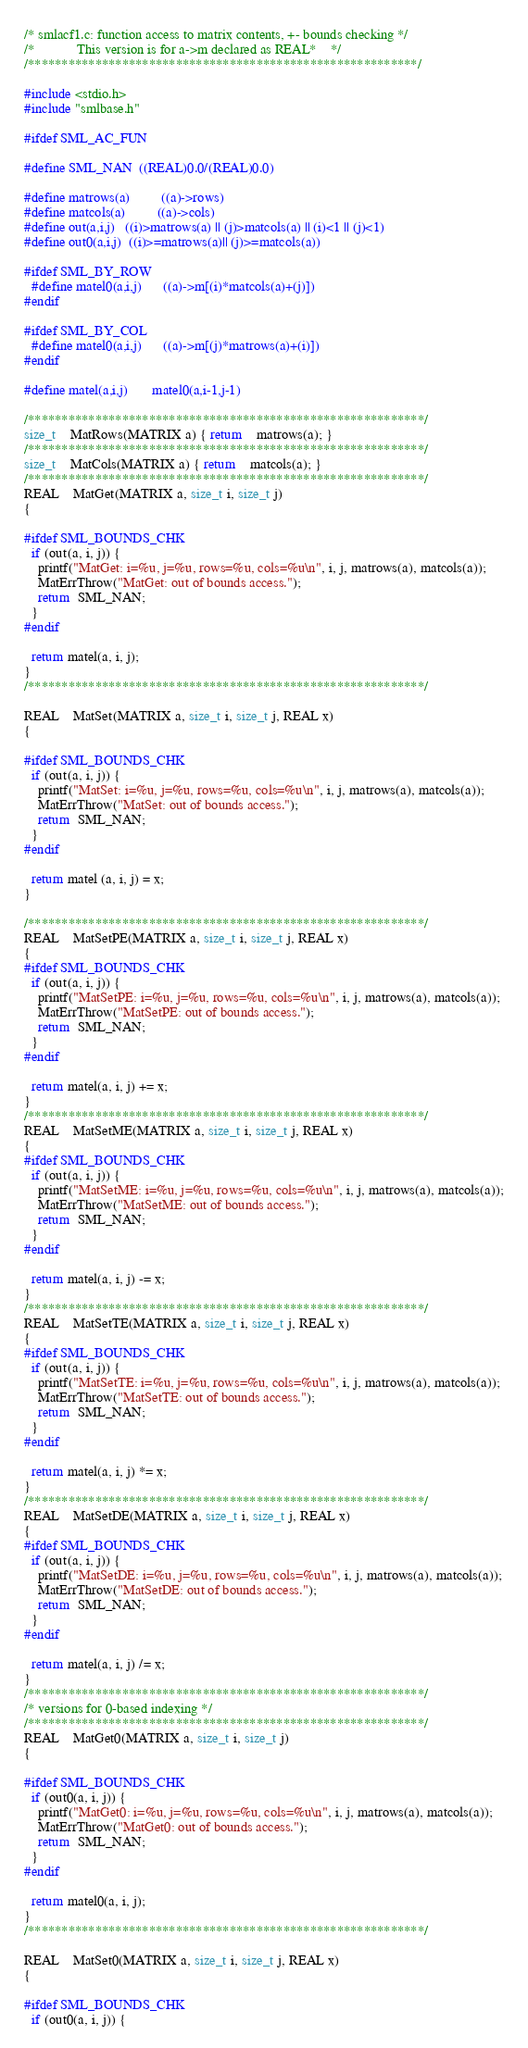Convert code to text. <code><loc_0><loc_0><loc_500><loc_500><_C_>/* smlacf1.c: function access to matrix contents, +- bounds checking */
/*            This version is for a->m declared as REAL*    */
/**********************************************************/

#include <stdio.h>
#include "smlbase.h"

#ifdef SML_AC_FUN

#define SML_NAN  ((REAL)0.0/(REAL)0.0)

#define matrows(a)         ((a)->rows)
#define matcols(a)         ((a)->cols)
#define out(a,i,j)   ((i)>matrows(a) || (j)>matcols(a) || (i)<1 || (j)<1)
#define out0(a,i,j)  ((i)>=matrows(a)|| (j)>=matcols(a))

#ifdef SML_BY_ROW
  #define matel0(a,i,j)      ((a)->m[(i)*matcols(a)+(j)])
#endif

#ifdef SML_BY_COL
  #define matel0(a,i,j)      ((a)->m[(j)*matrows(a)+(i)])
#endif

#define matel(a,i,j)       matel0(a,i-1,j-1)

/***********************************************************/
size_t    MatRows(MATRIX a) { return    matrows(a); }
/***********************************************************/
size_t    MatCols(MATRIX a) { return    matcols(a); }
/***********************************************************/
REAL    MatGet(MATRIX a, size_t i, size_t j)
{

#ifdef SML_BOUNDS_CHK
  if (out(a, i, j)) {
    printf("MatGet: i=%u, j=%u, rows=%u, cols=%u\n", i, j, matrows(a), matcols(a));
    MatErrThrow("MatGet: out of bounds access.");
    return  SML_NAN;
  }
#endif

  return matel(a, i, j);
}
/***********************************************************/

REAL    MatSet(MATRIX a, size_t i, size_t j, REAL x)
{

#ifdef SML_BOUNDS_CHK
  if (out(a, i, j)) {
    printf("MatSet: i=%u, j=%u, rows=%u, cols=%u\n", i, j, matrows(a), matcols(a));
    MatErrThrow("MatSet: out of bounds access.");
    return  SML_NAN;
  }
#endif

  return matel (a, i, j) = x;
}

/***********************************************************/
REAL    MatSetPE(MATRIX a, size_t i, size_t j, REAL x)
{
#ifdef SML_BOUNDS_CHK
  if (out(a, i, j)) {
    printf("MatSetPE: i=%u, j=%u, rows=%u, cols=%u\n", i, j, matrows(a), matcols(a));
    MatErrThrow("MatSetPE: out of bounds access.");
    return  SML_NAN;
  }
#endif

  return matel(a, i, j) += x;
}
/***********************************************************/
REAL    MatSetME(MATRIX a, size_t i, size_t j, REAL x)
{
#ifdef SML_BOUNDS_CHK
  if (out(a, i, j)) {
    printf("MatSetME: i=%u, j=%u, rows=%u, cols=%u\n", i, j, matrows(a), matcols(a));
    MatErrThrow("MatSetME: out of bounds access.");
    return  SML_NAN;
  }
#endif

  return matel(a, i, j) -= x;
}
/***********************************************************/
REAL    MatSetTE(MATRIX a, size_t i, size_t j, REAL x)
{
#ifdef SML_BOUNDS_CHK
  if (out(a, i, j)) {
    printf("MatSetTE: i=%u, j=%u, rows=%u, cols=%u\n", i, j, matrows(a), matcols(a));
    MatErrThrow("MatSetTE: out of bounds access.");
    return  SML_NAN;
  }
#endif

  return matel(a, i, j) *= x;
}
/***********************************************************/
REAL    MatSetDE(MATRIX a, size_t i, size_t j, REAL x)
{
#ifdef SML_BOUNDS_CHK
  if (out(a, i, j)) {
    printf("MatSetDE: i=%u, j=%u, rows=%u, cols=%u\n", i, j, matrows(a), matcols(a));
    MatErrThrow("MatSetDE: out of bounds access.");
    return  SML_NAN;
  }
#endif

  return matel(a, i, j) /= x;
}
/***********************************************************/
/* versions for 0-based indexing */
/***********************************************************/
REAL    MatGet0(MATRIX a, size_t i, size_t j)
{

#ifdef SML_BOUNDS_CHK
  if (out0(a, i, j)) {
    printf("MatGet0: i=%u, j=%u, rows=%u, cols=%u\n", i, j, matrows(a), matcols(a));
    MatErrThrow("MatGet0: out of bounds access.");
    return  SML_NAN;
  }
#endif

  return matel0(a, i, j);
}
/***********************************************************/

REAL    MatSet0(MATRIX a, size_t i, size_t j, REAL x)
{

#ifdef SML_BOUNDS_CHK
  if (out0(a, i, j)) {</code> 